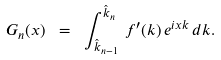Convert formula to latex. <formula><loc_0><loc_0><loc_500><loc_500>G _ { n } ( x ) \ = \ \int _ { \hat { k } _ { n - 1 } } ^ { \hat { k } _ { n } } \, f ^ { \prime } ( k ) \, e ^ { i x k } \, d k .</formula> 